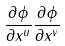Convert formula to latex. <formula><loc_0><loc_0><loc_500><loc_500>\frac { \partial \phi } { \partial x ^ { u } } \frac { \partial \phi } { \partial x ^ { v } }</formula> 